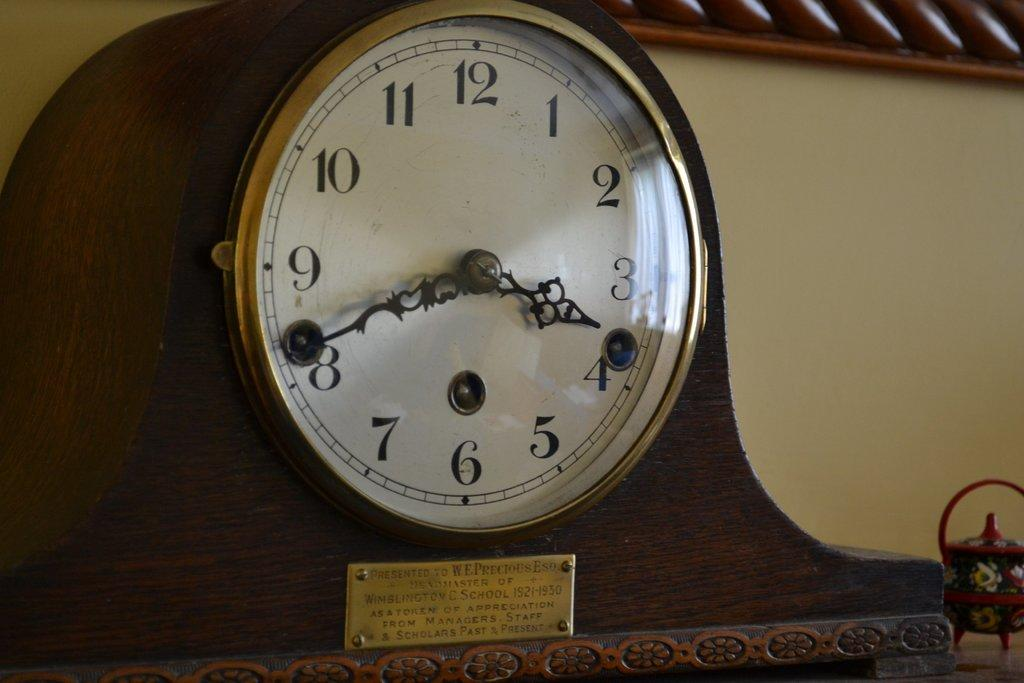<image>
Present a compact description of the photo's key features. an older clock with Wimblington C. School and more on the label. 